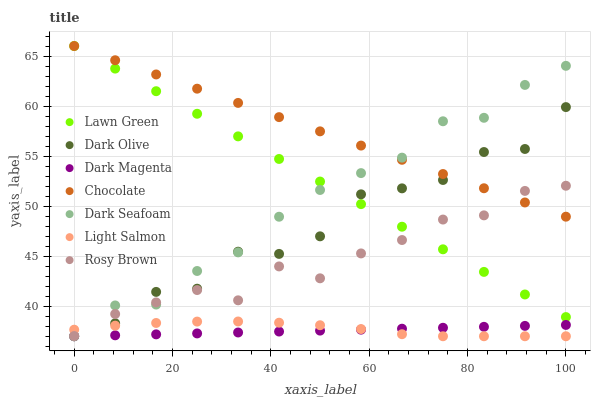Does Dark Magenta have the minimum area under the curve?
Answer yes or no. Yes. Does Chocolate have the maximum area under the curve?
Answer yes or no. Yes. Does Light Salmon have the minimum area under the curve?
Answer yes or no. No. Does Light Salmon have the maximum area under the curve?
Answer yes or no. No. Is Chocolate the smoothest?
Answer yes or no. Yes. Is Dark Olive the roughest?
Answer yes or no. Yes. Is Light Salmon the smoothest?
Answer yes or no. No. Is Light Salmon the roughest?
Answer yes or no. No. Does Light Salmon have the lowest value?
Answer yes or no. Yes. Does Rosy Brown have the lowest value?
Answer yes or no. No. Does Chocolate have the highest value?
Answer yes or no. Yes. Does Light Salmon have the highest value?
Answer yes or no. No. Is Light Salmon less than Chocolate?
Answer yes or no. Yes. Is Chocolate greater than Dark Magenta?
Answer yes or no. Yes. Does Lawn Green intersect Dark Olive?
Answer yes or no. Yes. Is Lawn Green less than Dark Olive?
Answer yes or no. No. Is Lawn Green greater than Dark Olive?
Answer yes or no. No. Does Light Salmon intersect Chocolate?
Answer yes or no. No. 